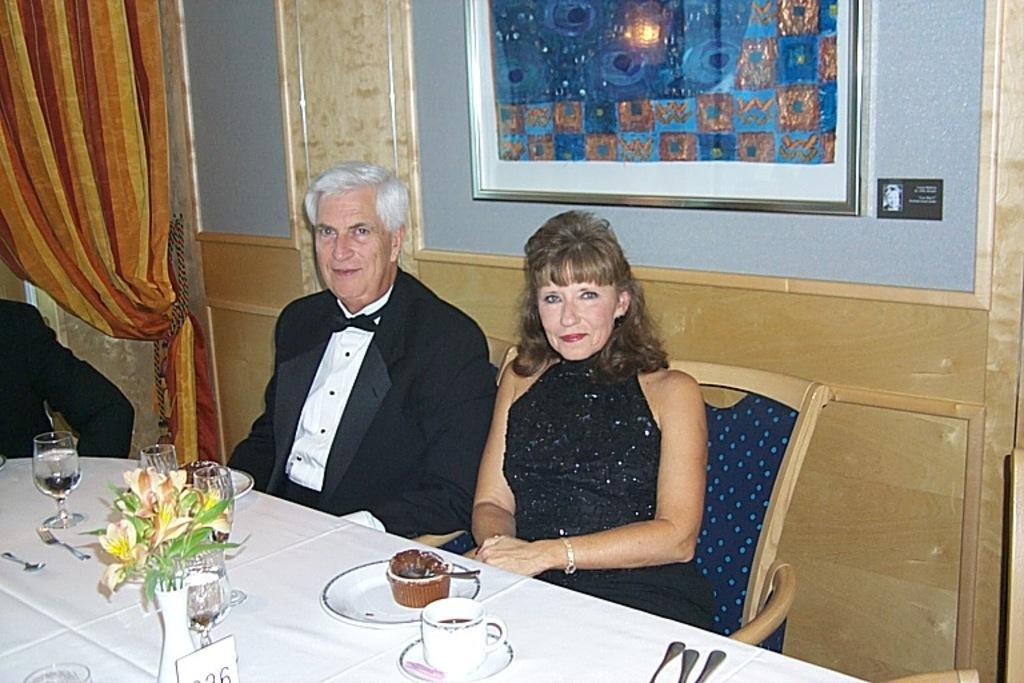How would you summarize this image in a sentence or two? in this image they are sitting on the chair in front of the table and behind the person the poster is there and the table there are somethings like flower vase,cup,glass and plate they are wearing black dress and the background is white. 